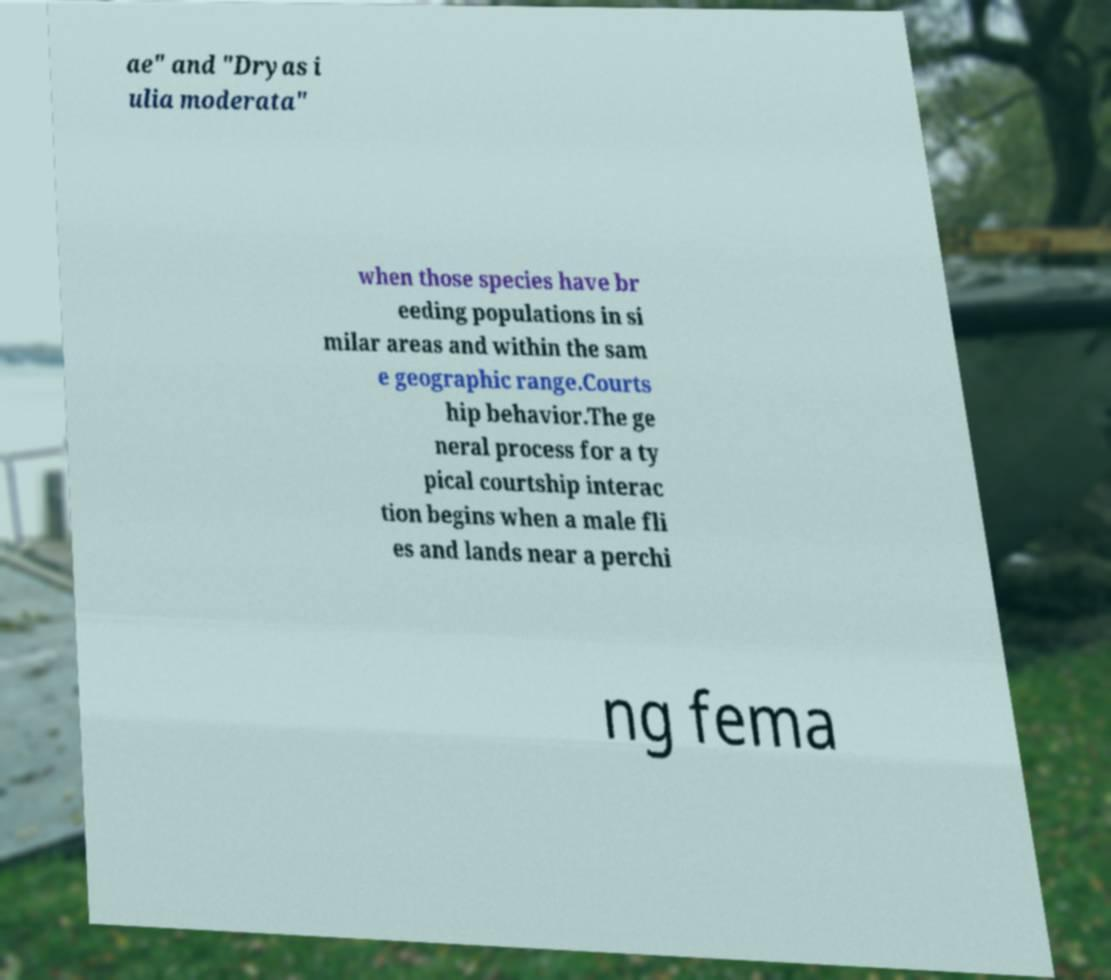Please identify and transcribe the text found in this image. ae" and "Dryas i ulia moderata" when those species have br eeding populations in si milar areas and within the sam e geographic range.Courts hip behavior.The ge neral process for a ty pical courtship interac tion begins when a male fli es and lands near a perchi ng fema 